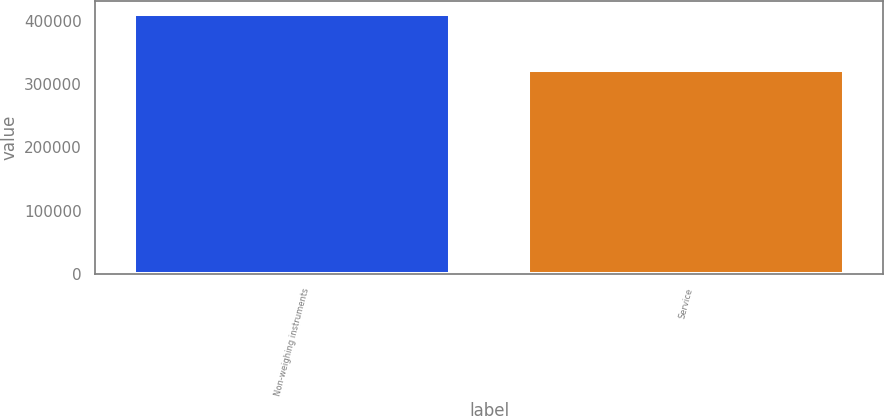<chart> <loc_0><loc_0><loc_500><loc_500><bar_chart><fcel>Non-weighing instruments<fcel>Service<nl><fcel>412086<fcel>322357<nl></chart> 